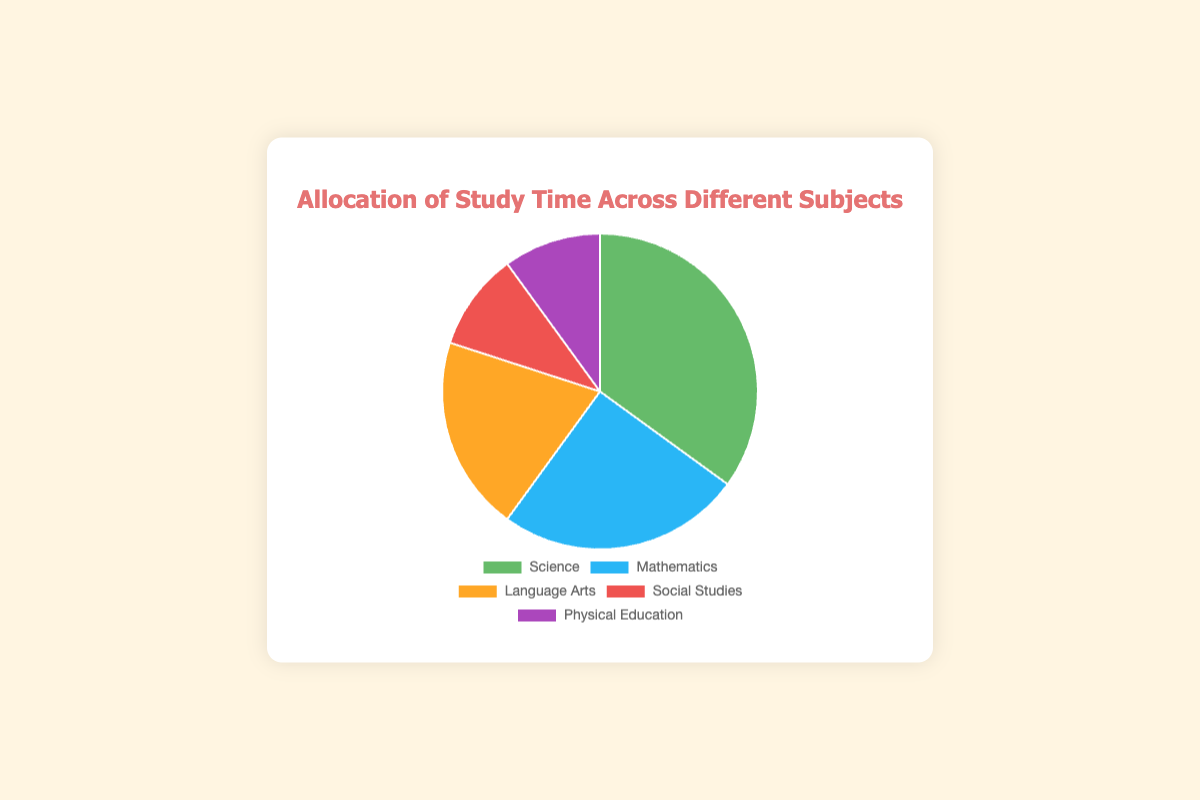What is the subject with the highest allocation of study time? The subject with the highest allocation of study time is the one with the largest percentage on the pie chart. In this case, it is Science with 35%.
Answer: Science What is the combined study time allocated to Social Studies and Physical Education? Add the percentages allocated to Social Studies and Physical Education: 10% + 10% = 20%.
Answer: 20% Which subject has a greater time allocation, Mathematics or Language Arts? Compare the percentages for Mathematics (25%) and Language Arts (20%). Mathematics has a greater allocation.
Answer: Mathematics How much more study time is allocated to Science compared to Physical Education? Subtract the percentage for Physical Education from the percentage for Science: 35% - 10% = 25%.
Answer: 25% What is the difference in study time allocation between the least and most allocated subjects? The most allocated subject is Science (35%) and the least allocated subjects are Social Studies and Physical Education (both 10%). The difference is 35% - 10% = 25%.
Answer: 25% Which color represents the subject with the second highest allocation of study time? The subject with the second highest allocation is Mathematics at 25%, and it is represented by the blue segment on the pie chart.
Answer: Blue How many subjects have an allocation of 20% or more? Identify subjects with allocations of at least 20%: Science (35%), Mathematics (25%), and Language Arts (20%). There are 3 subjects.
Answer: 3 Is the combined study time for Language Arts and Social Studies more or less than Science alone? Add the percentages for Language Arts (20%) and Social Studies (10%): 20% + 10% = 30%. Compare this with Science (35%). The combined study time is less.
Answer: Less What portion of the study time is allocated to subjects other than Science and Mathematics? Subtract the combined percentages of Science (35%) and Mathematics (25%) from 100%: 100% - 35% - 25% = 40%.
Answer: 40% If the study time for Physical Education were doubled, what fraction of total study time would it represent? Double the percentage for Physical Education: 10% * 2 = 20%. This would be 20% of the total study time.
Answer: 20% 